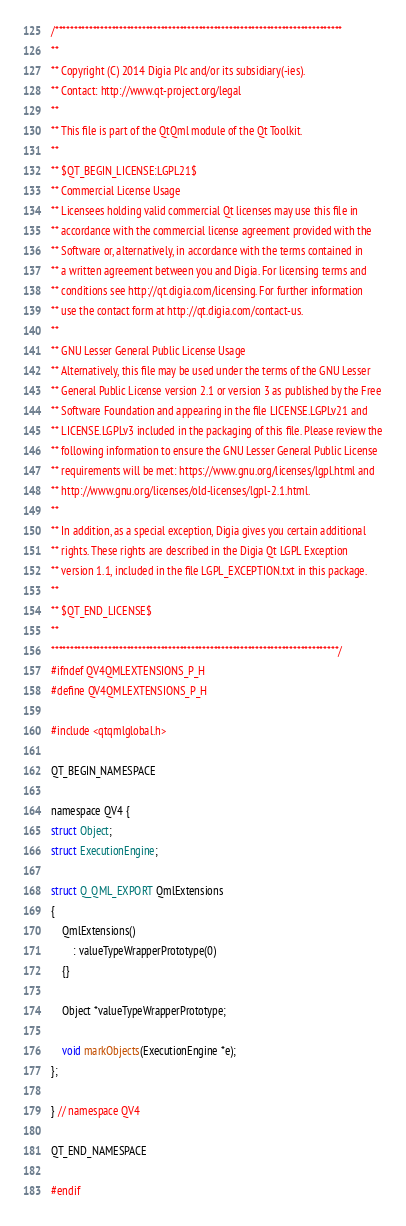Convert code to text. <code><loc_0><loc_0><loc_500><loc_500><_C_>/****************************************************************************
**
** Copyright (C) 2014 Digia Plc and/or its subsidiary(-ies).
** Contact: http://www.qt-project.org/legal
**
** This file is part of the QtQml module of the Qt Toolkit.
**
** $QT_BEGIN_LICENSE:LGPL21$
** Commercial License Usage
** Licensees holding valid commercial Qt licenses may use this file in
** accordance with the commercial license agreement provided with the
** Software or, alternatively, in accordance with the terms contained in
** a written agreement between you and Digia. For licensing terms and
** conditions see http://qt.digia.com/licensing. For further information
** use the contact form at http://qt.digia.com/contact-us.
**
** GNU Lesser General Public License Usage
** Alternatively, this file may be used under the terms of the GNU Lesser
** General Public License version 2.1 or version 3 as published by the Free
** Software Foundation and appearing in the file LICENSE.LGPLv21 and
** LICENSE.LGPLv3 included in the packaging of this file. Please review the
** following information to ensure the GNU Lesser General Public License
** requirements will be met: https://www.gnu.org/licenses/lgpl.html and
** http://www.gnu.org/licenses/old-licenses/lgpl-2.1.html.
**
** In addition, as a special exception, Digia gives you certain additional
** rights. These rights are described in the Digia Qt LGPL Exception
** version 1.1, included in the file LGPL_EXCEPTION.txt in this package.
**
** $QT_END_LICENSE$
**
****************************************************************************/
#ifndef QV4QMLEXTENSIONS_P_H
#define QV4QMLEXTENSIONS_P_H

#include <qtqmlglobal.h>

QT_BEGIN_NAMESPACE

namespace QV4 {
struct Object;
struct ExecutionEngine;

struct Q_QML_EXPORT QmlExtensions
{
    QmlExtensions()
        : valueTypeWrapperPrototype(0)
    {}

    Object *valueTypeWrapperPrototype;

    void markObjects(ExecutionEngine *e);
};

} // namespace QV4

QT_END_NAMESPACE

#endif
</code> 